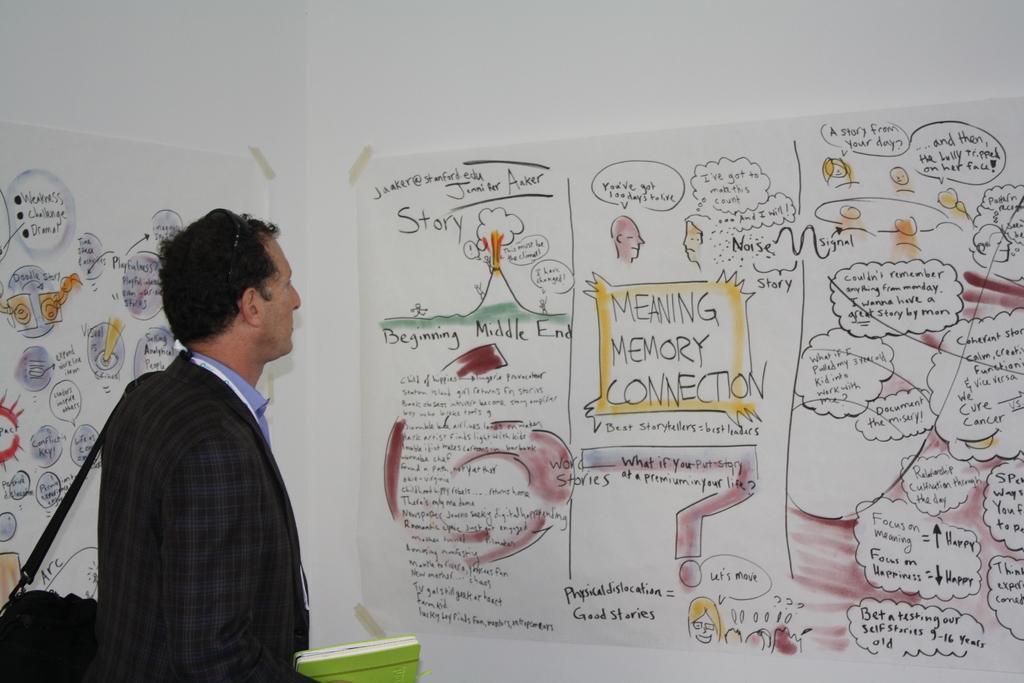<image>
Provide a brief description of the given image. Meaning Memory Connection on a poster telling a story 